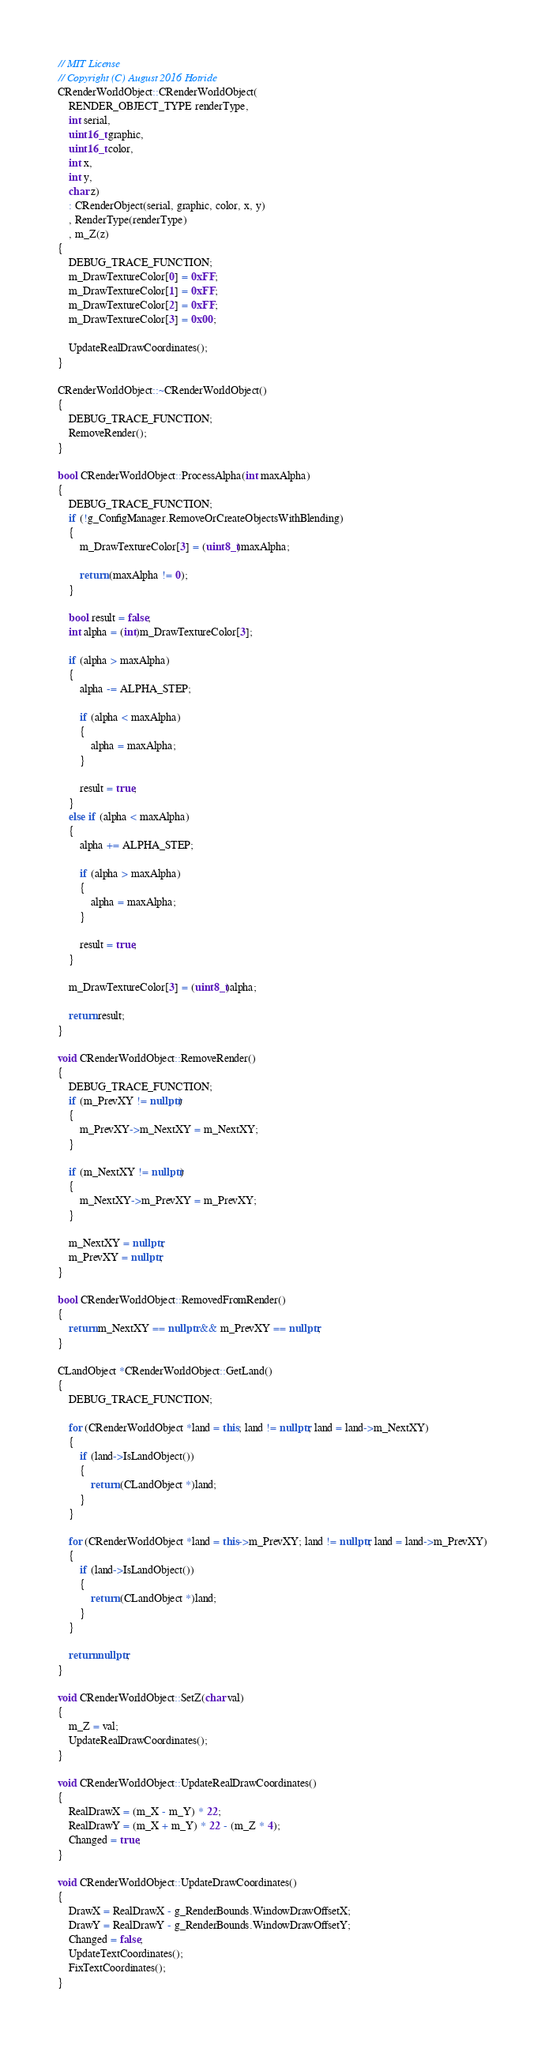<code> <loc_0><loc_0><loc_500><loc_500><_C++_>// MIT License
// Copyright (C) August 2016 Hotride
CRenderWorldObject::CRenderWorldObject(
    RENDER_OBJECT_TYPE renderType,
    int serial,
    uint16_t graphic,
    uint16_t color,
    int x,
    int y,
    char z)
    : CRenderObject(serial, graphic, color, x, y)
    , RenderType(renderType)
    , m_Z(z)
{
    DEBUG_TRACE_FUNCTION;
    m_DrawTextureColor[0] = 0xFF;
    m_DrawTextureColor[1] = 0xFF;
    m_DrawTextureColor[2] = 0xFF;
    m_DrawTextureColor[3] = 0x00;

    UpdateRealDrawCoordinates();
}

CRenderWorldObject::~CRenderWorldObject()
{
    DEBUG_TRACE_FUNCTION;
    RemoveRender();
}

bool CRenderWorldObject::ProcessAlpha(int maxAlpha)
{
    DEBUG_TRACE_FUNCTION;
    if (!g_ConfigManager.RemoveOrCreateObjectsWithBlending)
    {
        m_DrawTextureColor[3] = (uint8_t)maxAlpha;

        return (maxAlpha != 0);
    }

    bool result = false;
    int alpha = (int)m_DrawTextureColor[3];

    if (alpha > maxAlpha)
    {
        alpha -= ALPHA_STEP;

        if (alpha < maxAlpha)
        {
            alpha = maxAlpha;
        }

        result = true;
    }
    else if (alpha < maxAlpha)
    {
        alpha += ALPHA_STEP;

        if (alpha > maxAlpha)
        {
            alpha = maxAlpha;
        }

        result = true;
    }

    m_DrawTextureColor[3] = (uint8_t)alpha;

    return result;
}

void CRenderWorldObject::RemoveRender()
{
    DEBUG_TRACE_FUNCTION;
    if (m_PrevXY != nullptr)
    {
        m_PrevXY->m_NextXY = m_NextXY;
    }

    if (m_NextXY != nullptr)
    {
        m_NextXY->m_PrevXY = m_PrevXY;
    }

    m_NextXY = nullptr;
    m_PrevXY = nullptr;
}

bool CRenderWorldObject::RemovedFromRender()
{
    return m_NextXY == nullptr && m_PrevXY == nullptr;
}

CLandObject *CRenderWorldObject::GetLand()
{
    DEBUG_TRACE_FUNCTION;

    for (CRenderWorldObject *land = this; land != nullptr; land = land->m_NextXY)
    {
        if (land->IsLandObject())
        {
            return (CLandObject *)land;
        }
    }

    for (CRenderWorldObject *land = this->m_PrevXY; land != nullptr; land = land->m_PrevXY)
    {
        if (land->IsLandObject())
        {
            return (CLandObject *)land;
        }
    }

    return nullptr;
}

void CRenderWorldObject::SetZ(char val)
{
    m_Z = val;
    UpdateRealDrawCoordinates();
}

void CRenderWorldObject::UpdateRealDrawCoordinates()
{
    RealDrawX = (m_X - m_Y) * 22;
    RealDrawY = (m_X + m_Y) * 22 - (m_Z * 4);
    Changed = true;
}

void CRenderWorldObject::UpdateDrawCoordinates()
{
    DrawX = RealDrawX - g_RenderBounds.WindowDrawOffsetX;
    DrawY = RealDrawY - g_RenderBounds.WindowDrawOffsetY;
    Changed = false;
    UpdateTextCoordinates();
    FixTextCoordinates();
}
</code> 